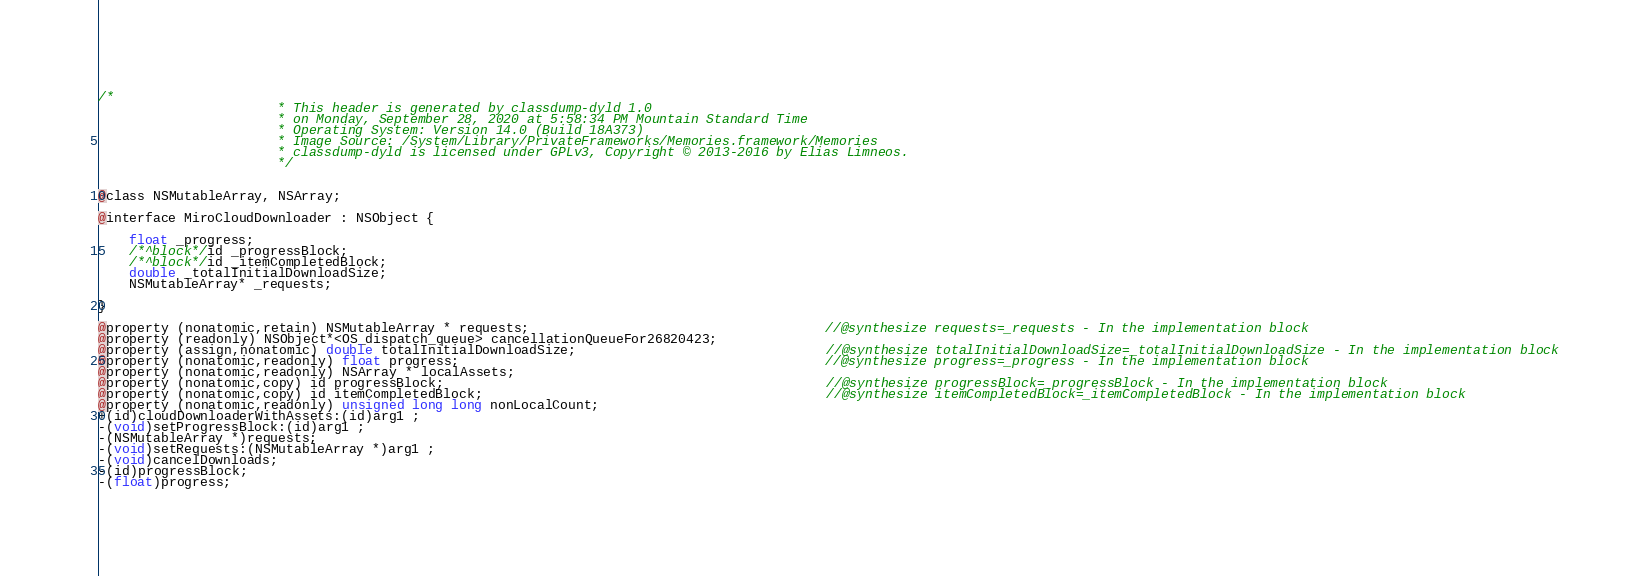<code> <loc_0><loc_0><loc_500><loc_500><_C_>/*
                       * This header is generated by classdump-dyld 1.0
                       * on Monday, September 28, 2020 at 5:58:34 PM Mountain Standard Time
                       * Operating System: Version 14.0 (Build 18A373)
                       * Image Source: /System/Library/PrivateFrameworks/Memories.framework/Memories
                       * classdump-dyld is licensed under GPLv3, Copyright © 2013-2016 by Elias Limneos.
                       */


@class NSMutableArray, NSArray;

@interface MiroCloudDownloader : NSObject {

	float _progress;
	/*^block*/id _progressBlock;
	/*^block*/id _itemCompletedBlock;
	double _totalInitialDownloadSize;
	NSMutableArray* _requests;

}

@property (nonatomic,retain) NSMutableArray * requests;                                      //@synthesize requests=_requests - In the implementation block
@property (readonly) NSObject*<OS_dispatch_queue> cancellationQueueFor26820423; 
@property (assign,nonatomic) double totalInitialDownloadSize;                                //@synthesize totalInitialDownloadSize=_totalInitialDownloadSize - In the implementation block
@property (nonatomic,readonly) float progress;                                               //@synthesize progress=_progress - In the implementation block
@property (nonatomic,readonly) NSArray * localAssets; 
@property (nonatomic,copy) id progressBlock;                                                 //@synthesize progressBlock=_progressBlock - In the implementation block
@property (nonatomic,copy) id itemCompletedBlock;                                            //@synthesize itemCompletedBlock=_itemCompletedBlock - In the implementation block
@property (nonatomic,readonly) unsigned long long nonLocalCount; 
+(id)cloudDownloaderWithAssets:(id)arg1 ;
-(void)setProgressBlock:(id)arg1 ;
-(NSMutableArray *)requests;
-(void)setRequests:(NSMutableArray *)arg1 ;
-(void)cancelDownloads;
-(id)progressBlock;
-(float)progress;</code> 